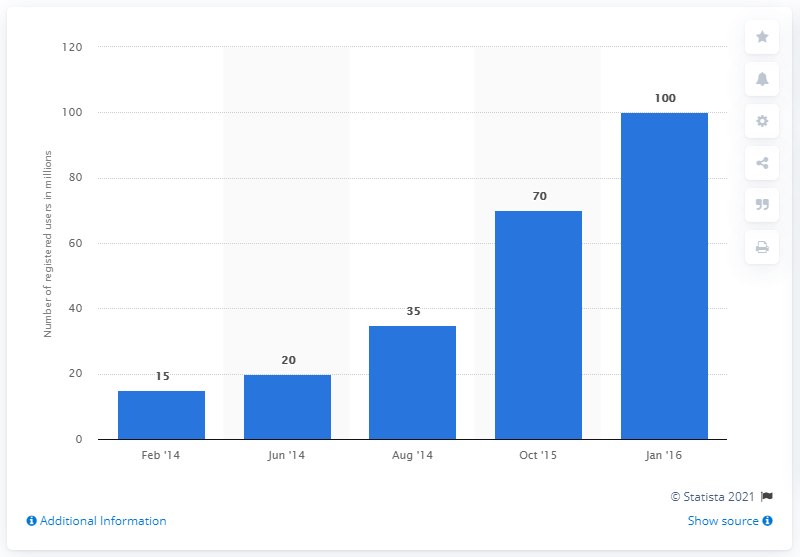Outline some significant characteristics in this image. In January 2016, the Hike chat app had approximately 100 registered users. 